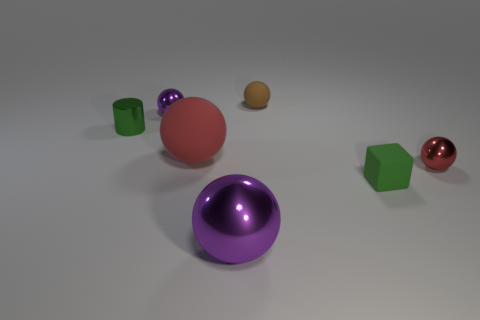Can you describe the objects and their arrangement on the surface? Certainly! The image shows a collection of objects on a flat surface. There are two spheres, one large red sphere and one smaller brown sphere. There are also two cubes, one green and one translucent, and a purple object that seems to be a sphere with a reflective surface. The arrangement is somewhat scattered, with no discernible pattern. 